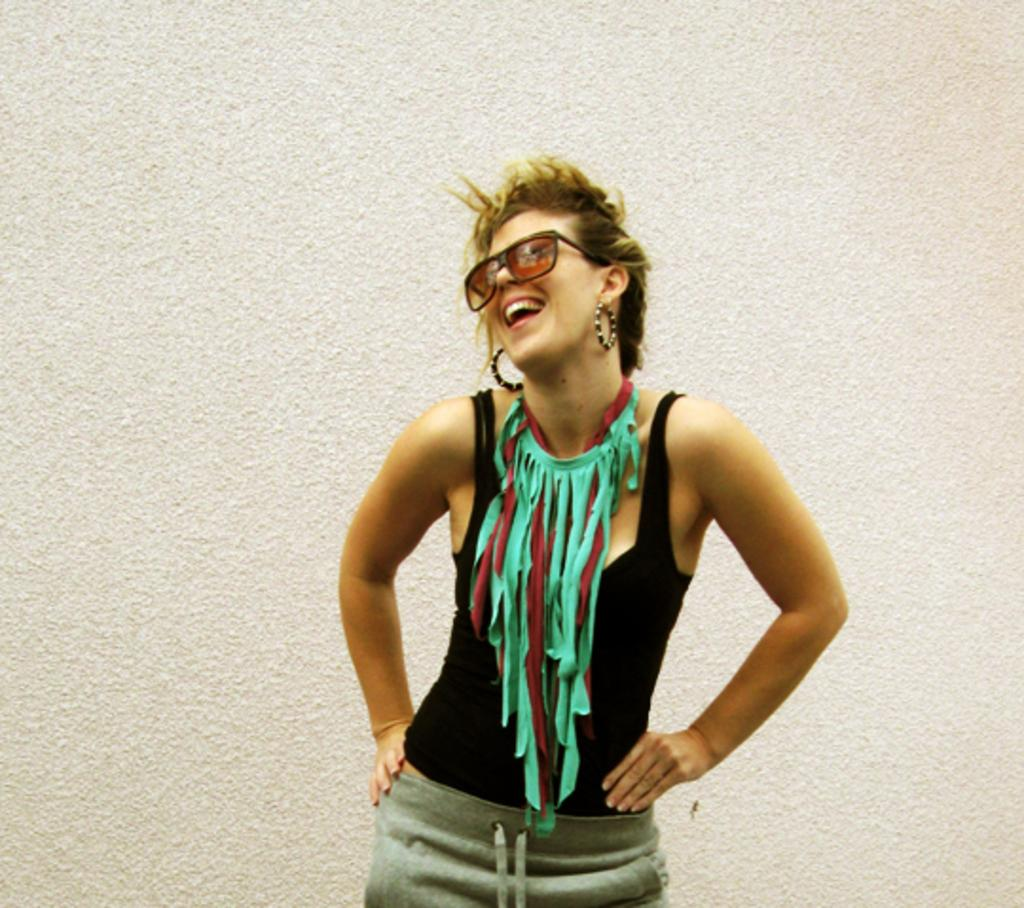Who is the main subject in the image? There is a girl in the image. What is the girl doing in the image? The girl is standing and smiling. What can be seen behind the girl in the image? There is a wall behind the girl. What type of ink is the girl using to write on the wall in the image? There is no ink or writing on the wall in the image; the girl is simply standing in front of it. 